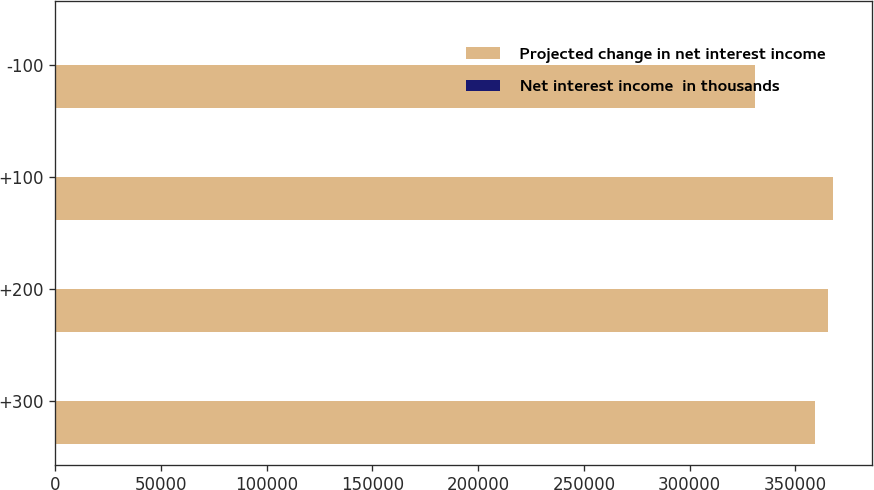Convert chart to OTSL. <chart><loc_0><loc_0><loc_500><loc_500><stacked_bar_chart><ecel><fcel>+300<fcel>+200<fcel>+100<fcel>-100<nl><fcel>Projected change in net interest income<fcel>359150<fcel>365585<fcel>367813<fcel>331083<nl><fcel>Net interest income  in thousands<fcel>3.77<fcel>5.63<fcel>6.27<fcel>4.34<nl></chart> 